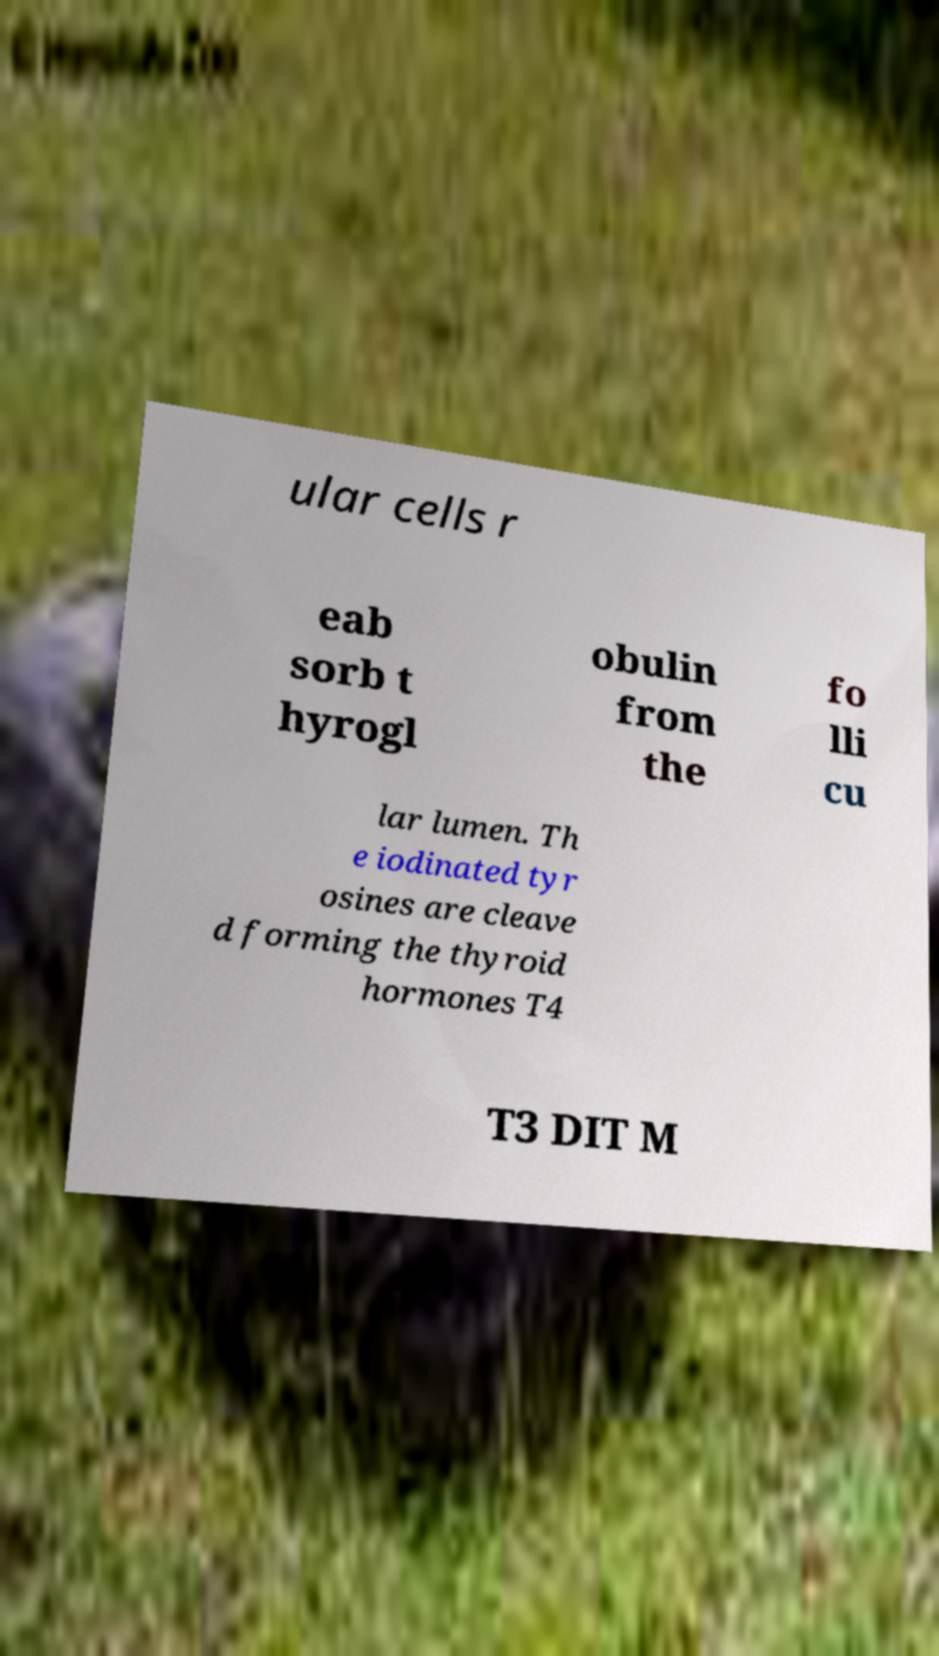There's text embedded in this image that I need extracted. Can you transcribe it verbatim? ular cells r eab sorb t hyrogl obulin from the fo lli cu lar lumen. Th e iodinated tyr osines are cleave d forming the thyroid hormones T4 T3 DIT M 